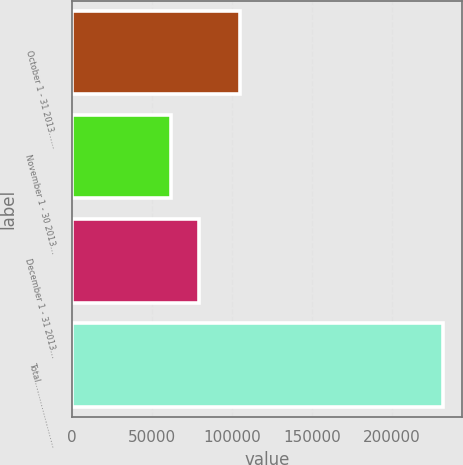<chart> <loc_0><loc_0><loc_500><loc_500><bar_chart><fcel>October 1 - 31 2013……<fcel>November 1 - 30 2013…<fcel>December 1 - 31 2013…<fcel>Total……………………<nl><fcel>105167<fcel>62312<fcel>79290.7<fcel>232099<nl></chart> 